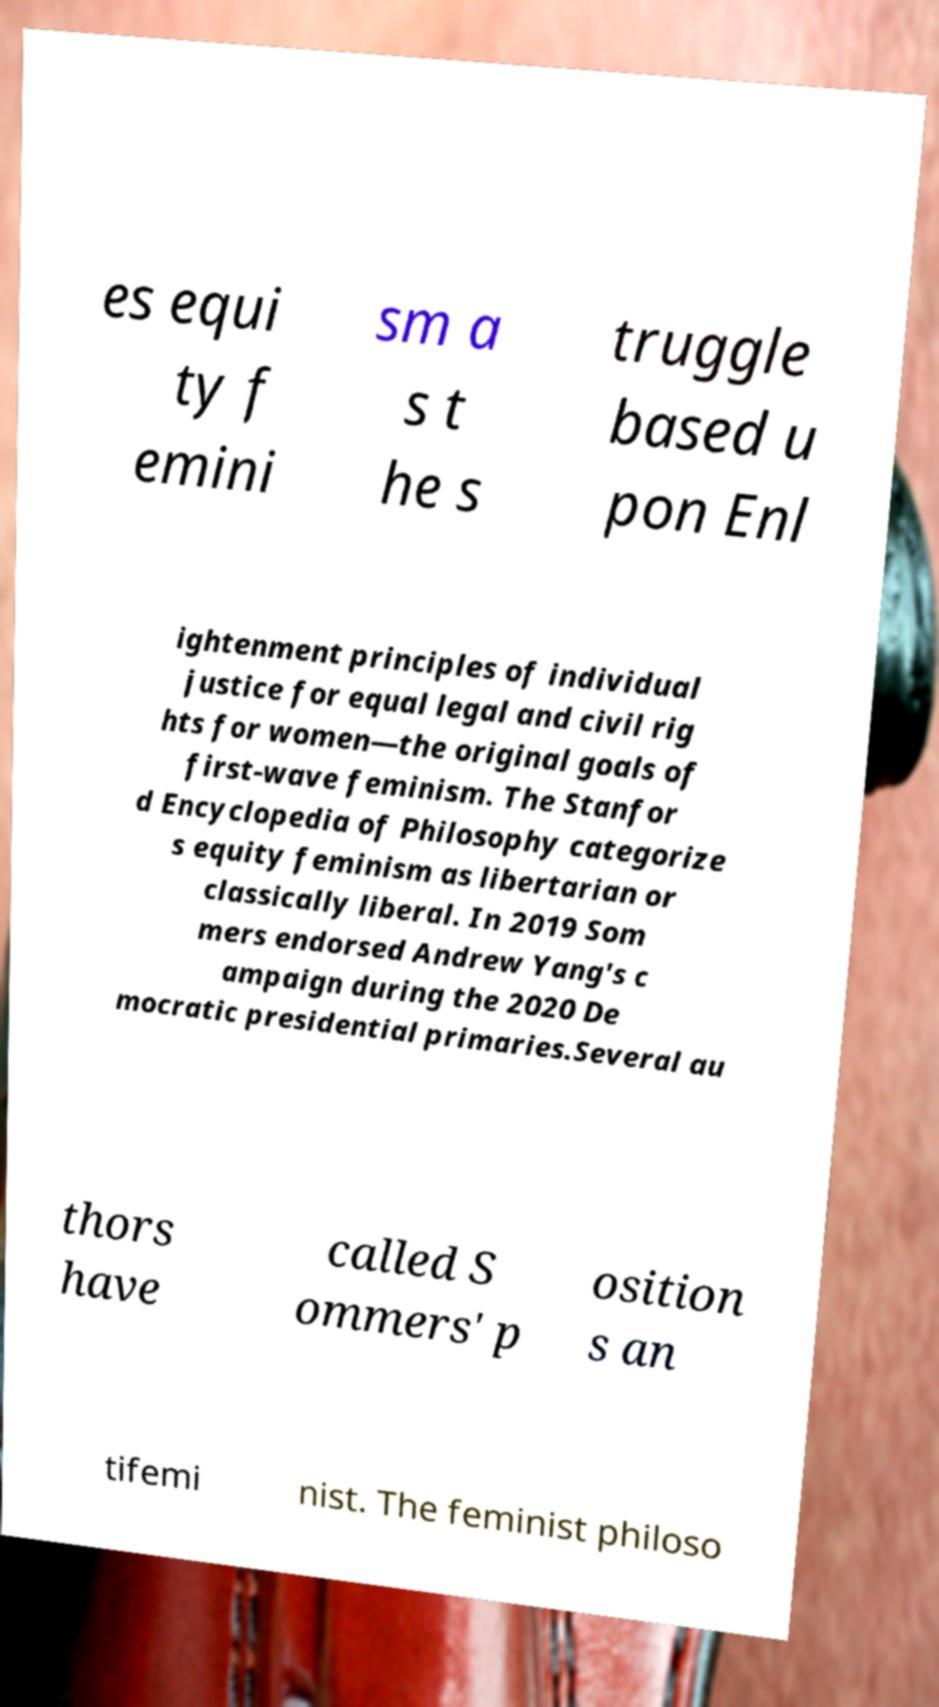Can you accurately transcribe the text from the provided image for me? es equi ty f emini sm a s t he s truggle based u pon Enl ightenment principles of individual justice for equal legal and civil rig hts for women—the original goals of first-wave feminism. The Stanfor d Encyclopedia of Philosophy categorize s equity feminism as libertarian or classically liberal. In 2019 Som mers endorsed Andrew Yang's c ampaign during the 2020 De mocratic presidential primaries.Several au thors have called S ommers' p osition s an tifemi nist. The feminist philoso 